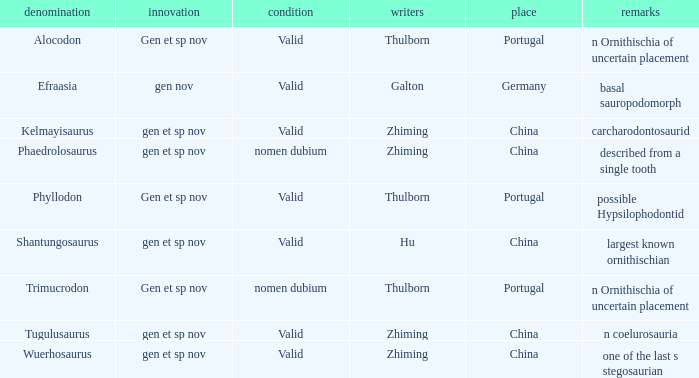Could you parse the entire table as a dict? {'header': ['denomination', 'innovation', 'condition', 'writers', 'place', 'remarks'], 'rows': [['Alocodon', 'Gen et sp nov', 'Valid', 'Thulborn', 'Portugal', 'n Ornithischia of uncertain placement'], ['Efraasia', 'gen nov', 'Valid', 'Galton', 'Germany', 'basal sauropodomorph'], ['Kelmayisaurus', 'gen et sp nov', 'Valid', 'Zhiming', 'China', 'carcharodontosaurid'], ['Phaedrolosaurus', 'gen et sp nov', 'nomen dubium', 'Zhiming', 'China', 'described from a single tooth'], ['Phyllodon', 'Gen et sp nov', 'Valid', 'Thulborn', 'Portugal', 'possible Hypsilophodontid'], ['Shantungosaurus', 'gen et sp nov', 'Valid', 'Hu', 'China', 'largest known ornithischian'], ['Trimucrodon', 'Gen et sp nov', 'nomen dubium', 'Thulborn', 'Portugal', 'n Ornithischia of uncertain placement'], ['Tugulusaurus', 'gen et sp nov', 'Valid', 'Zhiming', 'China', 'n coelurosauria'], ['Wuerhosaurus', 'gen et sp nov', 'Valid', 'Zhiming', 'China', 'one of the last s stegosaurian']]} What is the Name of the dinosaur, whose notes are, "n ornithischia of uncertain placement"? Alocodon, Trimucrodon. 